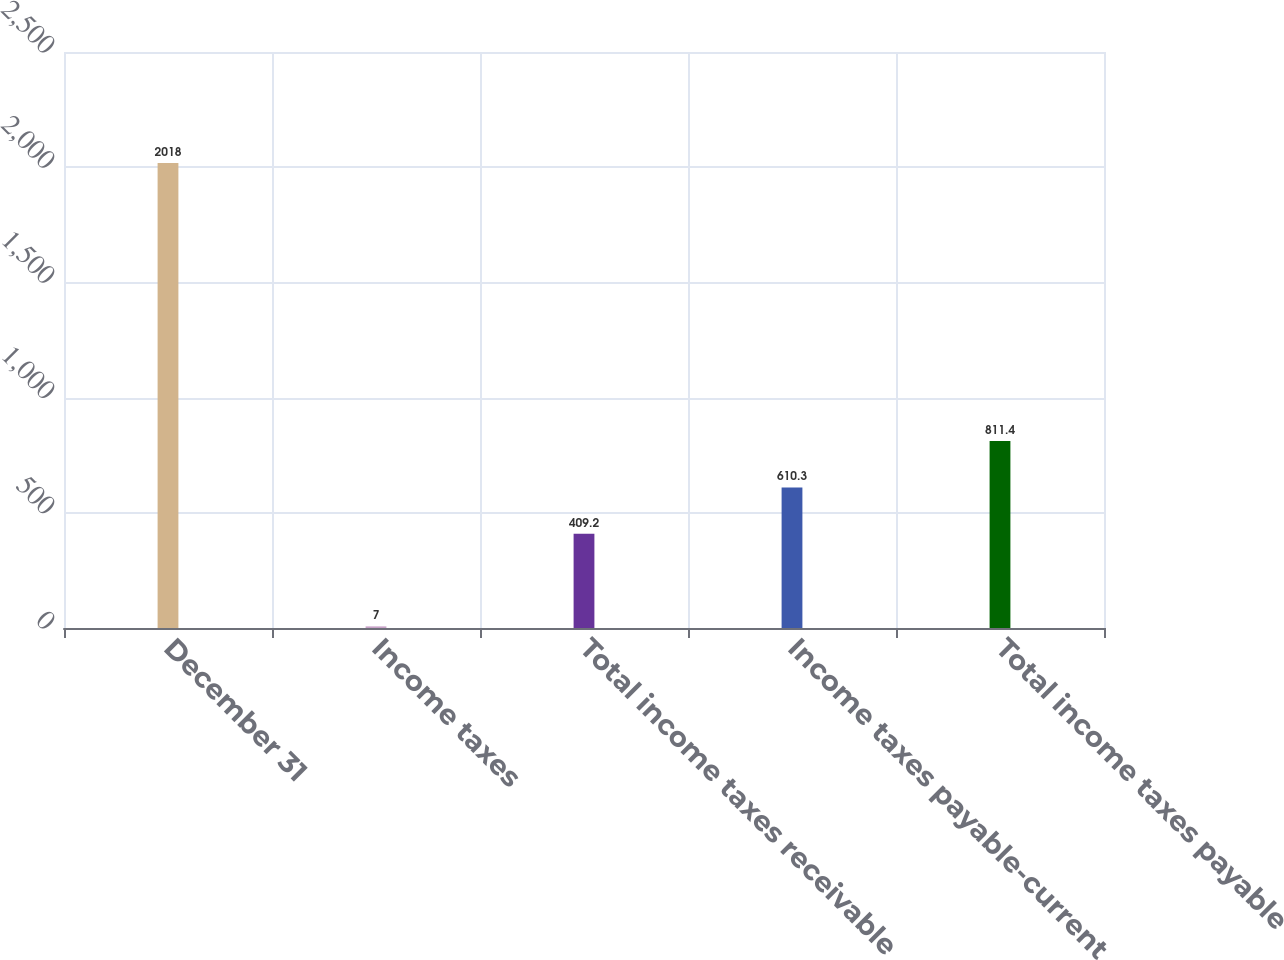Convert chart. <chart><loc_0><loc_0><loc_500><loc_500><bar_chart><fcel>December 31<fcel>Income taxes<fcel>Total income taxes receivable<fcel>Income taxes payable-current<fcel>Total income taxes payable<nl><fcel>2018<fcel>7<fcel>409.2<fcel>610.3<fcel>811.4<nl></chart> 